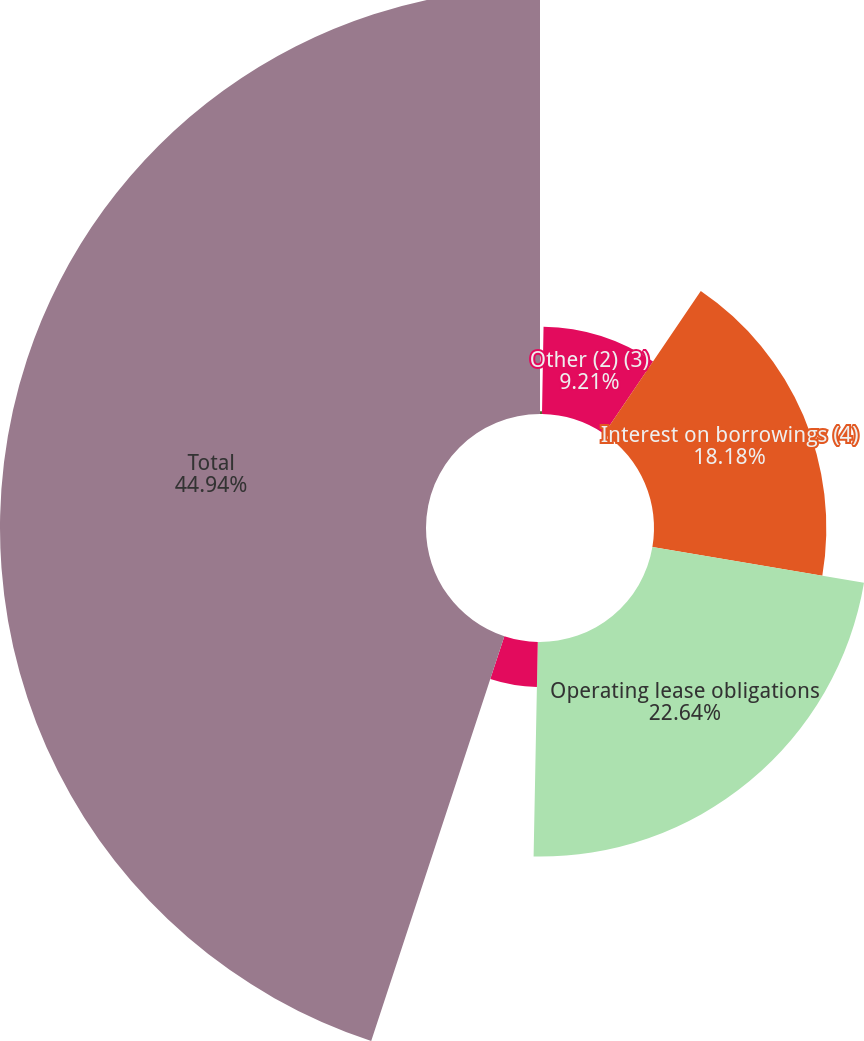Convert chart. <chart><loc_0><loc_0><loc_500><loc_500><pie_chart><fcel>Long-term debt (1)<fcel>Other (2) (3)<fcel>Interest on borrowings (4)<fcel>Operating lease obligations<fcel>Other (7)<fcel>Total<nl><fcel>0.28%<fcel>9.21%<fcel>18.18%<fcel>22.64%<fcel>4.75%<fcel>44.94%<nl></chart> 